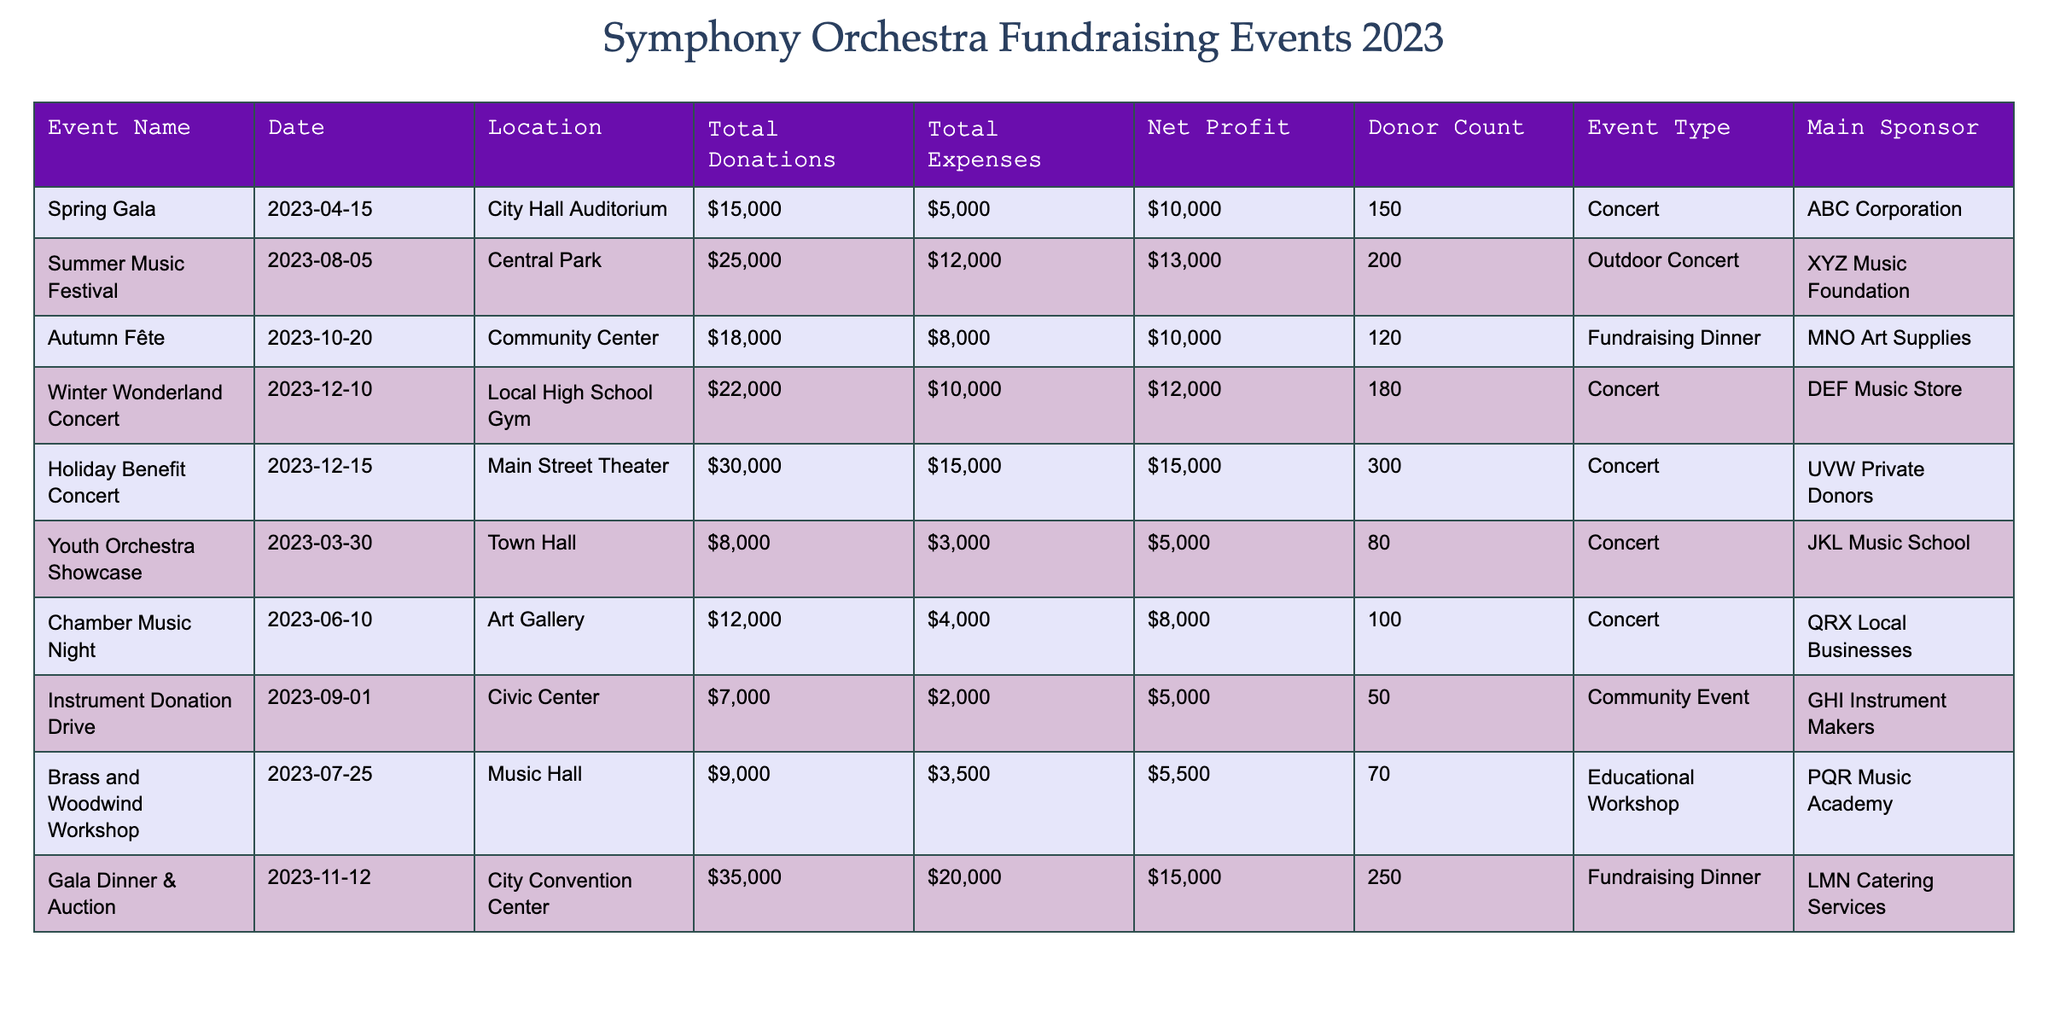What was the total profit from the Holiday Benefit Concert? The Profit for the Holiday Benefit Concert is listed in the table as $15,000.
Answer: $15,000 How many events had total donations between $10,000 and $20,000? The events with total donations between $10,000 and $20,000 are: Spring Gala ($15,000), Autumn Fête ($18,000), and Chamber Music Night ($12,000), totaling 3 events.
Answer: 3 events Which event had the highest donor count? The event with the highest donor count is the Holiday Benefit Concert, which had 300 donors.
Answer: 300 What is the total amount spent on all fundraising events? The total expenses are: $5,000 (Spring Gala) + $12,000 (Summer Music Festival) + $8,000 (Autumn Fête) + $10,000 (Winter Wonderland) + $15,000 (Holiday Benefit) + $3,000 (Youth Orchestra) + $4,000 (Chamber Music Night) + $2,000 (Instrument Drive) + $3,500 (Brass and Woodwind) + $20,000 (Gala Dinner) = $92,500.
Answer: $92,500 Did the Instrument Donation Drive generate more profit than the Youth Orchestra Showcase? The profit for the Instrument Donation Drive was $5,000, while the Youth Orchestra Showcase generated $5,000 too, so they are equal, making it false that the Instrument Donation Drive made more.
Answer: No What is the average net profit across all the events? The net profits from the events are: $10,000 (Spring Gala), $13,000 (Summer Music Festival), $10,000 (Autumn Fête), $12,000 (Winter Wonderland), $15,000 (Holiday Benefit), $5,000 (Youth Orchestra), $8,000 (Chamber Music Night), $5,000 (Instrument Drive), $5,500 (Brass and Woodwind), $15,000 (Gala Dinner). Total is $10,000 + $13,000 + $10,000 + $12,000 + $15,000 + $5,000 + $8,000 + $5,000 + $5,500 + $15,000 = $93,500. There are 10 events, so the average is $93,500 / 10 = $9,350.
Answer: $9,350 What percentage of total donations were raised at the Summer Music Festival? Total donations are $15,000 + $25,000 + $18,000 + $22,000 + $30,000 + $8,000 + $12,000 + $7,000 + $9,000 + $35,000 = $231,000. The Summer Music Festival raised $25,000. To find the percentage, ($25,000 / $231,000) * 100 = 10.83%.
Answer: 10.83% Which event was held first in 2023? The first event listed is the Youth Orchestra Showcase on March 30, 2023.
Answer: Youth Orchestra Showcase How much more was spent on the Gala Dinner & Auction compared to the Winter Wonderland Concert? The Gala Dinner & Auction had total expenses of $20,000, while the Winter Wonderland Concert had expenses of $10,000. The difference is $20,000 - $10,000 = $10,000.
Answer: $10,000 Is there any event that had the same total donations and expenses? No events had equal total donations and expenses, as all the values in the table are different.
Answer: No 